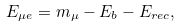<formula> <loc_0><loc_0><loc_500><loc_500>E _ { \mu e } = m _ { \mu } - E _ { b } - E _ { r e c } ,</formula> 